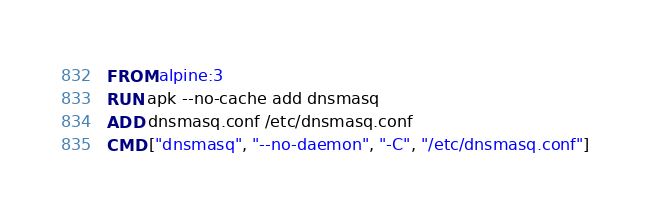Convert code to text. <code><loc_0><loc_0><loc_500><loc_500><_Dockerfile_>FROM alpine:3
RUN apk --no-cache add dnsmasq
ADD dnsmasq.conf /etc/dnsmasq.conf
CMD ["dnsmasq", "--no-daemon", "-C", "/etc/dnsmasq.conf"]
</code> 